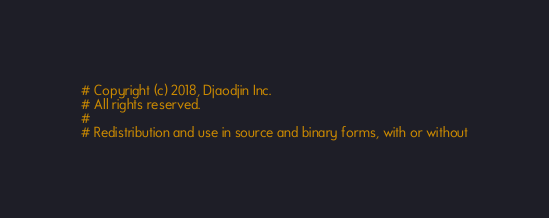Convert code to text. <code><loc_0><loc_0><loc_500><loc_500><_Python_># Copyright (c) 2018, Djaodjin Inc.
# All rights reserved.
#
# Redistribution and use in source and binary forms, with or without</code> 